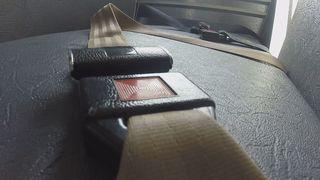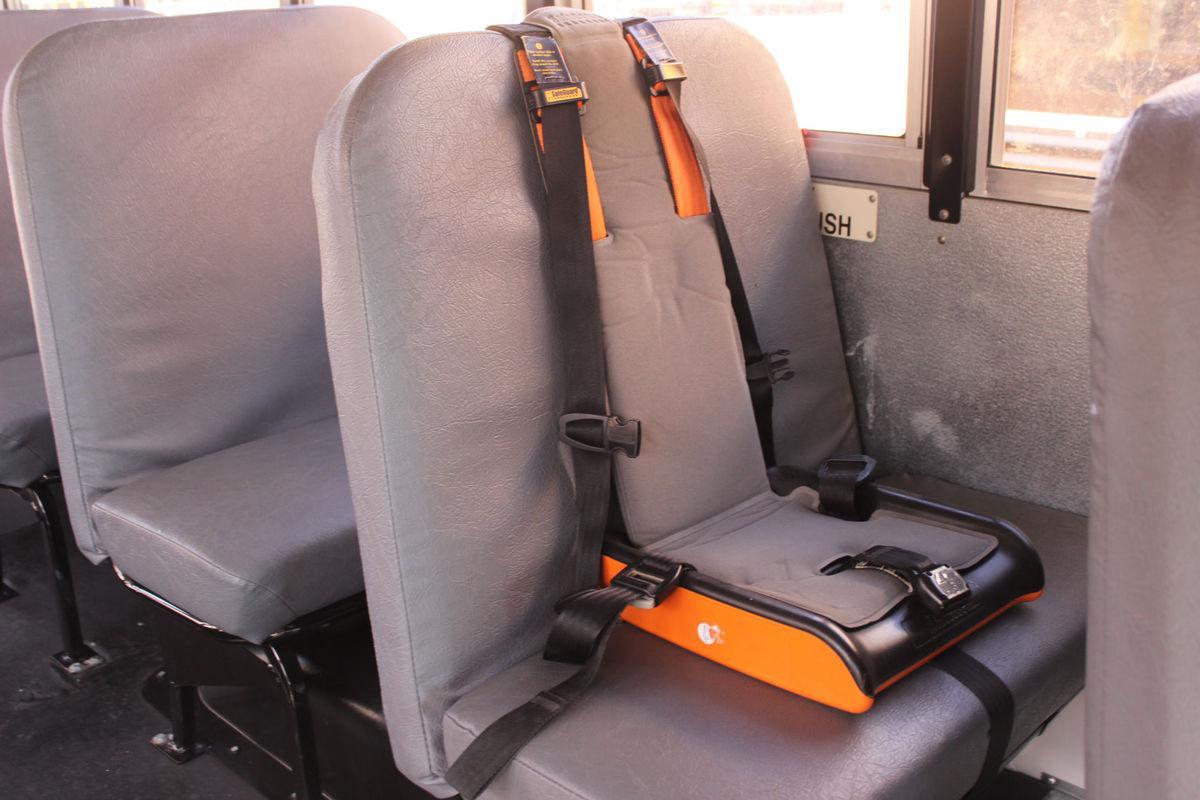The first image is the image on the left, the second image is the image on the right. Assess this claim about the two images: "In one of the images only the seat belts are shown.". Correct or not? Answer yes or no. Yes. The first image is the image on the left, the second image is the image on the right. Examine the images to the left and right. Is the description "The left image shows an empty gray seat with two seat buckles and straps on the seat back." accurate? Answer yes or no. No. 